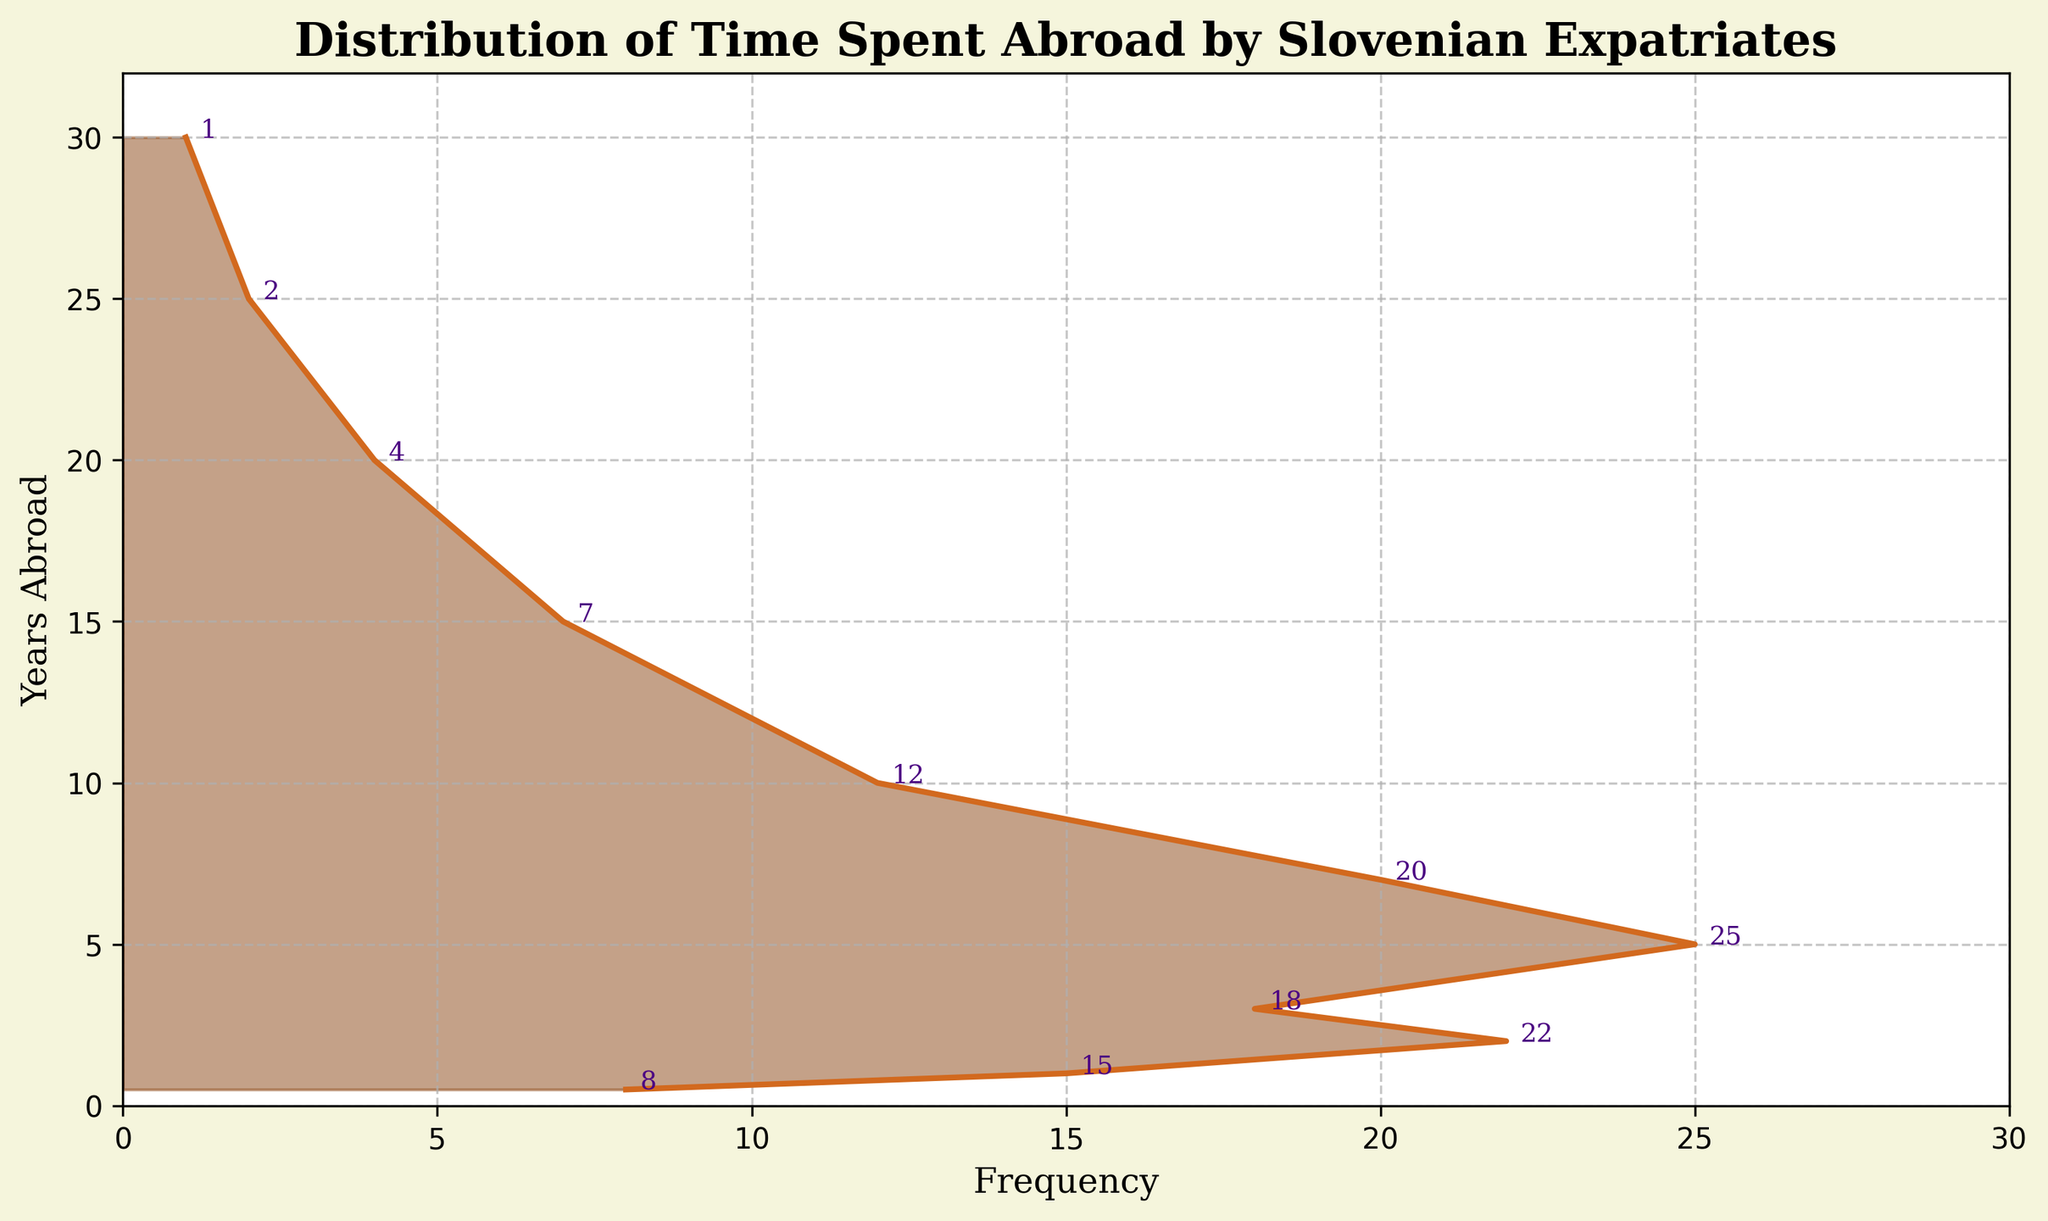What's the primary color used in the density plot's area? The figure uses a brownish color to fill the density plot area.
Answer: Brown How many years are represented in the data? By counting the data points along the Y-axis, we find there are 11 different years represented in the plot.
Answer: 11 What is the frequency for those who have spent 3 years abroad? Refer to the annotation on the plot next to 3 on the Y-axis, which shows the frequency is 18.
Answer: 18 Which number of years abroad has the highest frequency? By locating the tallest peak on the plot or checking annotations, we see that 5 years abroad has the highest frequency of 25.
Answer: 25 What is the frequency range shown on the X-axis? The X-axis ranges from 0 to approximately 30, as seen by the tick marks and axis limits.
Answer: 0 to 30 How many individuals have spent 10 or more years abroad? Sum the frequencies for 10, 15, 20, 25, and 30 years: 12 + 7 + 4 + 2 + 1 = 26.
Answer: 26 What is the median value of the frequency data? To find the median, list the frequencies in order: 1, 2, 4, 7, 8, 12, 15, 18, 20, 22, 25. The middle value (6th position) is 12.
Answer: 12 What is the average length of time spent abroad? Using the formula (ΣFrequency*Years)/ΣFrequency: ((8*0.5) + (15*1) + (22*2) + (18*3) + (25*5) + (20*7) + (12*10) + (7*15) + (4*20) + (2*25) + (1*30))/(8+15+22+18+25+20+12+7+4+2+1) = (4+15+44+54+125+140+120+105+80+50+30)/134 ≈ 665/134 ≈ 4.96.
Answer: 4.96 Between 1 and 2 years abroad, how does the frequency change? The frequency increases from 15 at 1 year to 22 at 2 years, showing an increase of 7.
Answer: Increased by 7 What’s the overall trend in terms of frequency as the years spent abroad increase? The frequency gradually increases to a peak at 5 years and then generally decreases as the years abroad increase further.
Answer: Increases to peak at 5 years then decreases 